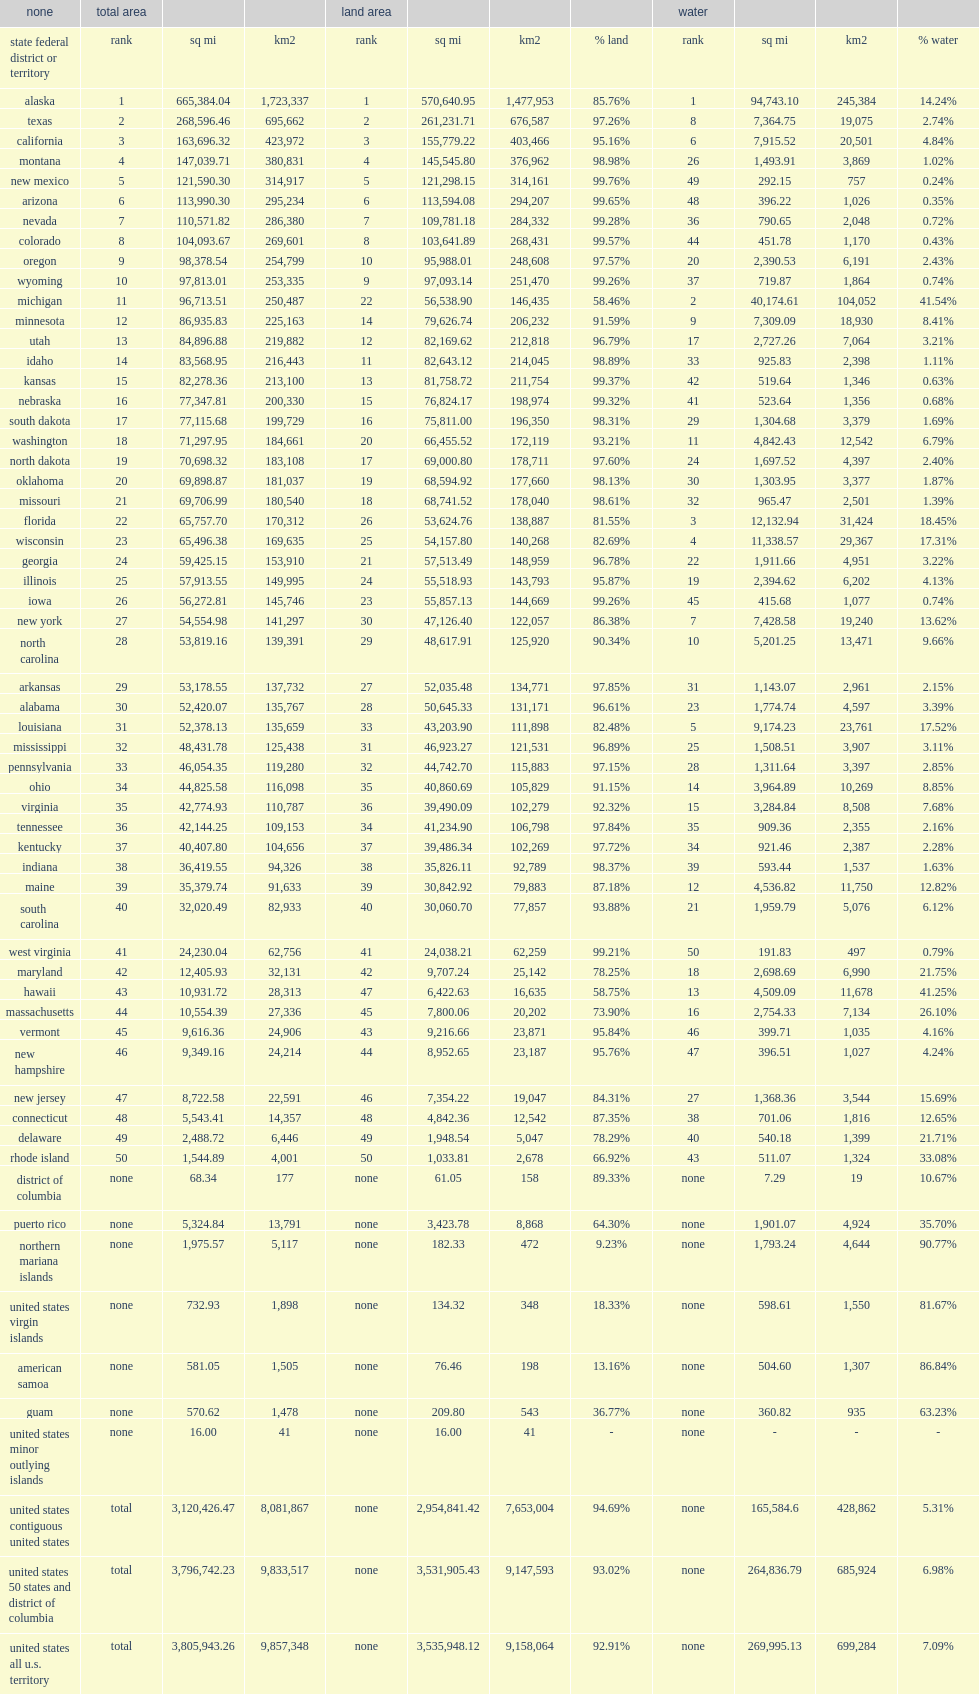What was the rank of arizona? 6.0. 